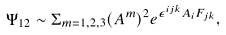<formula> <loc_0><loc_0><loc_500><loc_500>\Psi _ { 1 2 } \sim \Sigma _ { m = 1 , 2 , 3 } ( A ^ { m } ) ^ { 2 } e ^ { \epsilon ^ { i j k } A _ { i } F _ { j k } } ,</formula> 